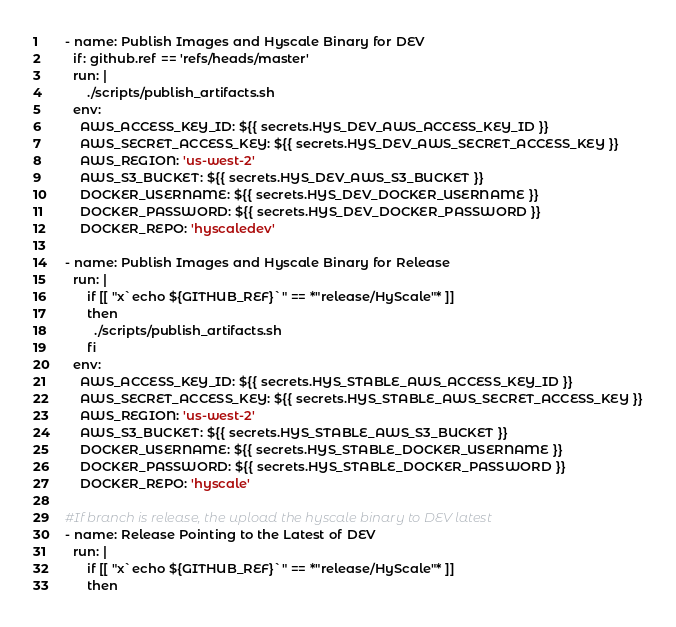Convert code to text. <code><loc_0><loc_0><loc_500><loc_500><_YAML_>    - name: Publish Images and Hyscale Binary for DEV
      if: github.ref == 'refs/heads/master'
      run: |
          ./scripts/publish_artifacts.sh
      env:
        AWS_ACCESS_KEY_ID: ${{ secrets.HYS_DEV_AWS_ACCESS_KEY_ID }}
        AWS_SECRET_ACCESS_KEY: ${{ secrets.HYS_DEV_AWS_SECRET_ACCESS_KEY }}
        AWS_REGION: 'us-west-2'
        AWS_S3_BUCKET: ${{ secrets.HYS_DEV_AWS_S3_BUCKET }}
        DOCKER_USERNAME: ${{ secrets.HYS_DEV_DOCKER_USERNAME }}
        DOCKER_PASSWORD: ${{ secrets.HYS_DEV_DOCKER_PASSWORD }}
        DOCKER_REPO: 'hyscaledev'

    - name: Publish Images and Hyscale Binary for Release
      run: |
          if [[ "x`echo ${GITHUB_REF}`" == *"release/HyScale"* ]]
          then
            ./scripts/publish_artifacts.sh
          fi
      env:
        AWS_ACCESS_KEY_ID: ${{ secrets.HYS_STABLE_AWS_ACCESS_KEY_ID }}
        AWS_SECRET_ACCESS_KEY: ${{ secrets.HYS_STABLE_AWS_SECRET_ACCESS_KEY }}
        AWS_REGION: 'us-west-2'
        AWS_S3_BUCKET: ${{ secrets.HYS_STABLE_AWS_S3_BUCKET }}
        DOCKER_USERNAME: ${{ secrets.HYS_STABLE_DOCKER_USERNAME }}
        DOCKER_PASSWORD: ${{ secrets.HYS_STABLE_DOCKER_PASSWORD }}
        DOCKER_REPO: 'hyscale'

    #If branch is release, the upload the hyscale binary to DEV latest
    - name: Release Pointing to the Latest of DEV
      run: |
          if [[ "x`echo ${GITHUB_REF}`" == *"release/HyScale"* ]]
          then</code> 